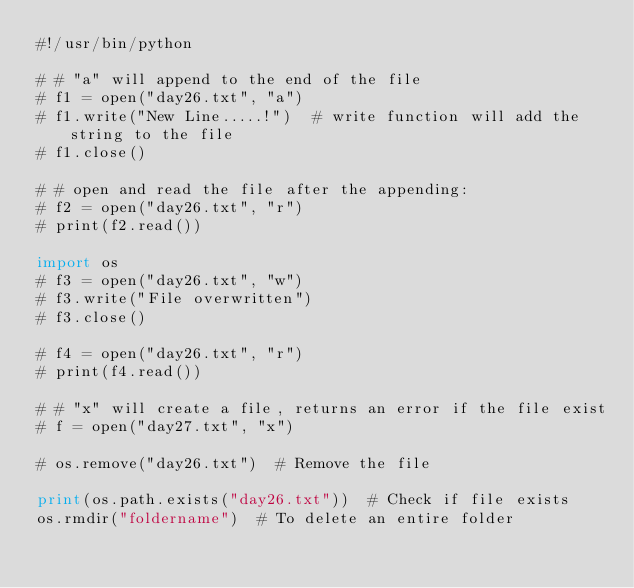Convert code to text. <code><loc_0><loc_0><loc_500><loc_500><_Python_>#!/usr/bin/python

# # "a" will append to the end of the file
# f1 = open("day26.txt", "a")
# f1.write("New Line.....!")  # write function will add the string to the file
# f1.close()

# # open and read the file after the appending:
# f2 = open("day26.txt", "r")
# print(f2.read())

import os
# f3 = open("day26.txt", "w")
# f3.write("File overwritten")
# f3.close()

# f4 = open("day26.txt", "r")
# print(f4.read())

# # "x" will create a file, returns an error if the file exist
# f = open("day27.txt", "x")

# os.remove("day26.txt")  # Remove the file

print(os.path.exists("day26.txt"))  # Check if file exists
os.rmdir("foldername")  # To delete an entire folder
</code> 